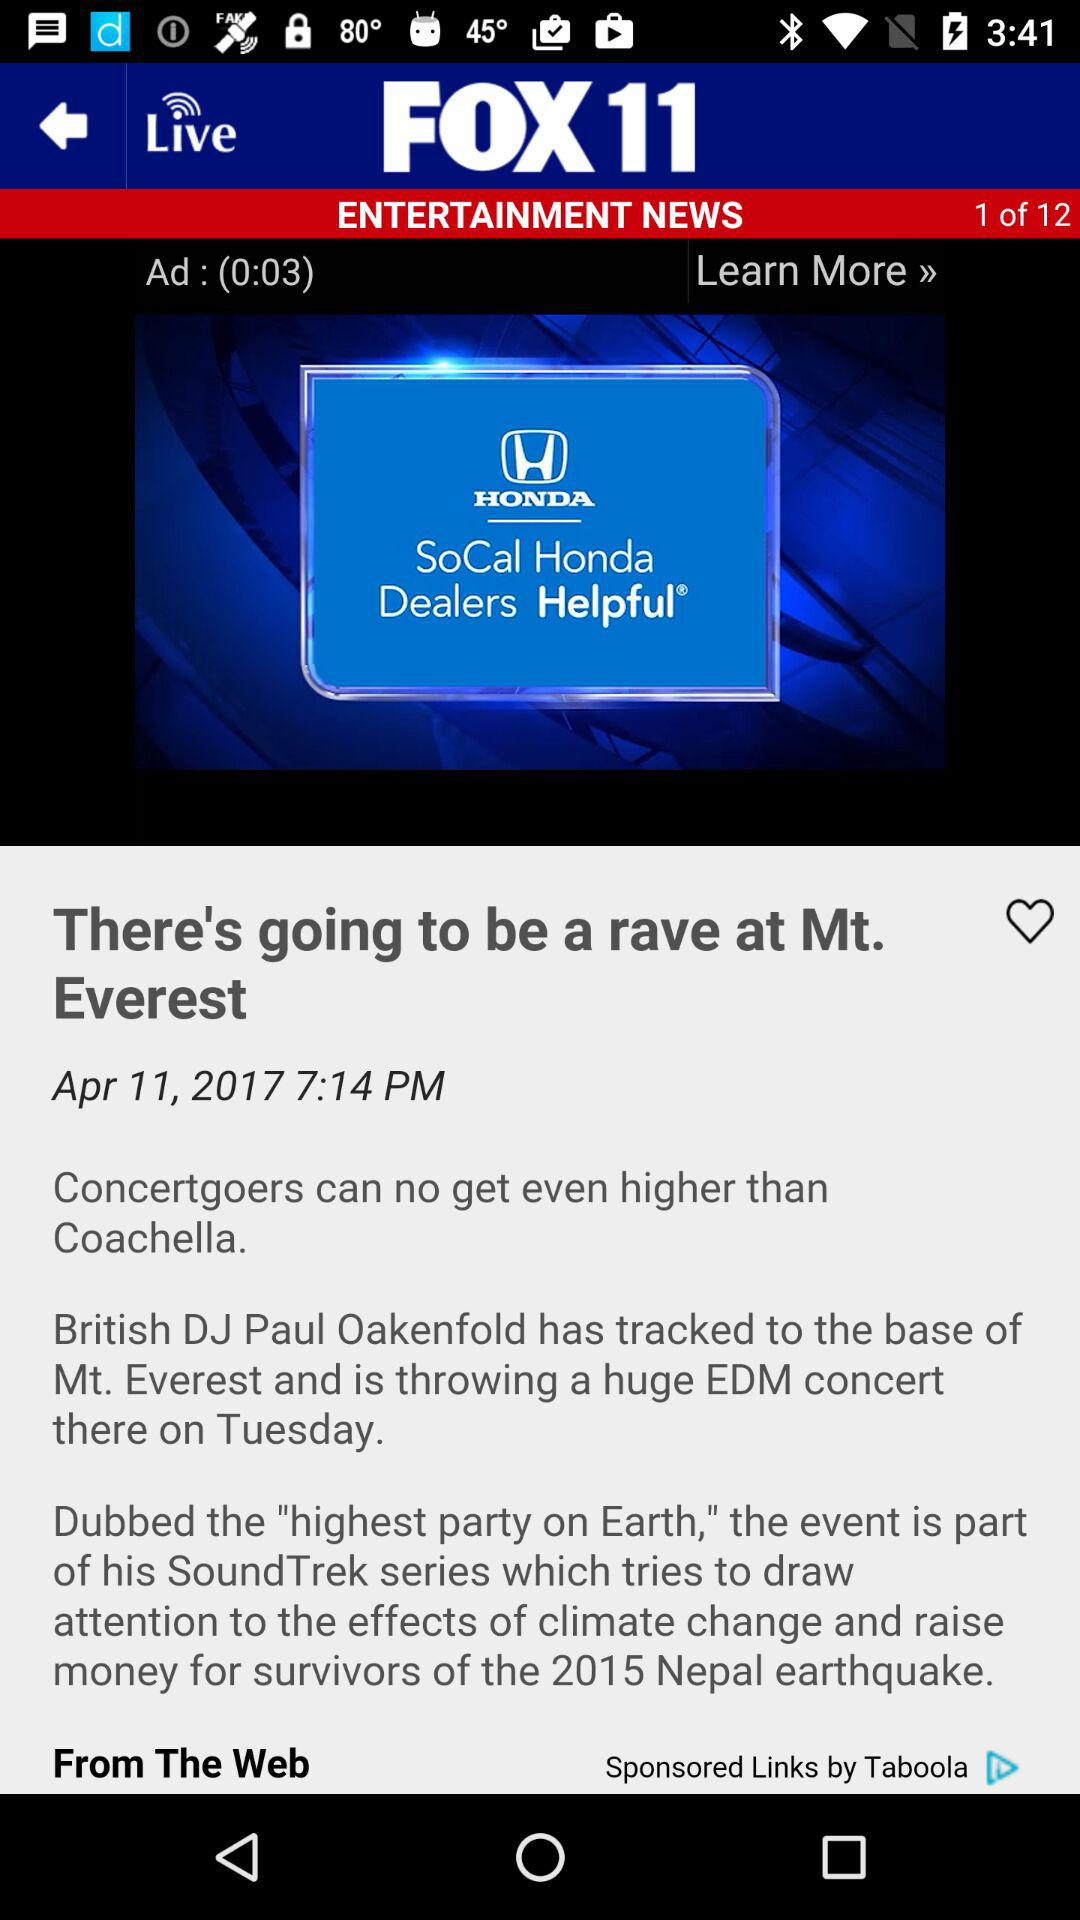What is the total number of news stories? The total number of news stories is 12. 